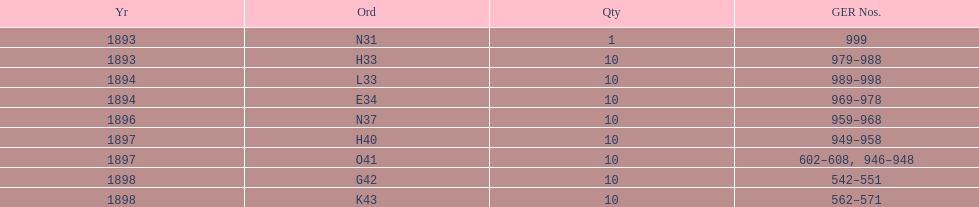Which had more ger numbers, 1898 or 1893? 1898. 